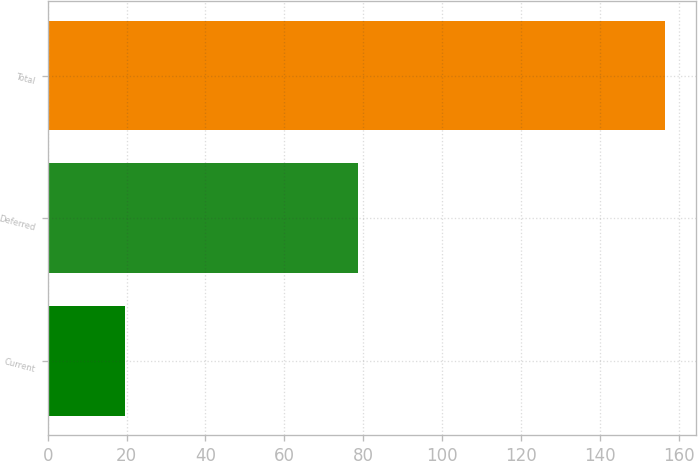<chart> <loc_0><loc_0><loc_500><loc_500><bar_chart><fcel>Current<fcel>Deferred<fcel>Total<nl><fcel>19.7<fcel>78.8<fcel>156.6<nl></chart> 